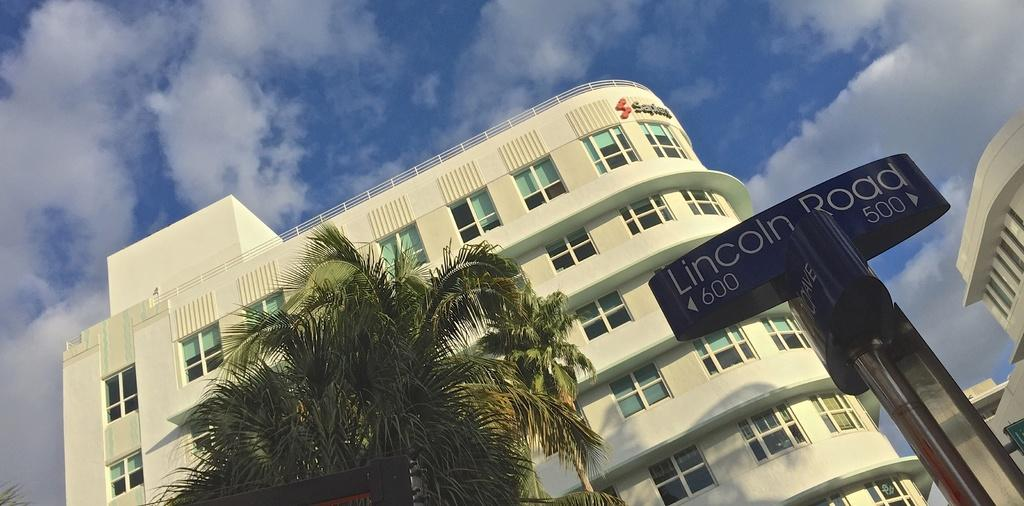What type of structures can be seen in the image? There are buildings in the image. What object is present in the image that is typically used for support or signage? There is a pole in the image. What can be read or deciphered in the image? There is a board with text in the image. What type of vegetation is visible at the bottom of the image? There are trees at the bottom of the image. What part of the natural environment is visible in the image? The sky is visible at the top of the image. What type of quill is being used to write on the board in the image? There is no quill present in the image; the board with text appears to be a sign or advertisement. What type of jar can be seen on the pole in the image? There is no jar present on the pole in the image; only a pole and a board with text are visible. 